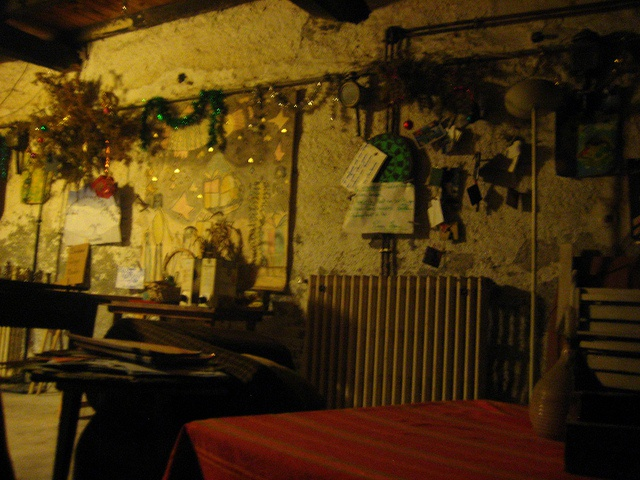Describe the objects in this image and their specific colors. I can see dining table in black, maroon, and darkgreen tones, chair in black, olive, and maroon tones, vase in black, maroon, and olive tones, book in black and maroon tones, and book in black and maroon tones in this image. 